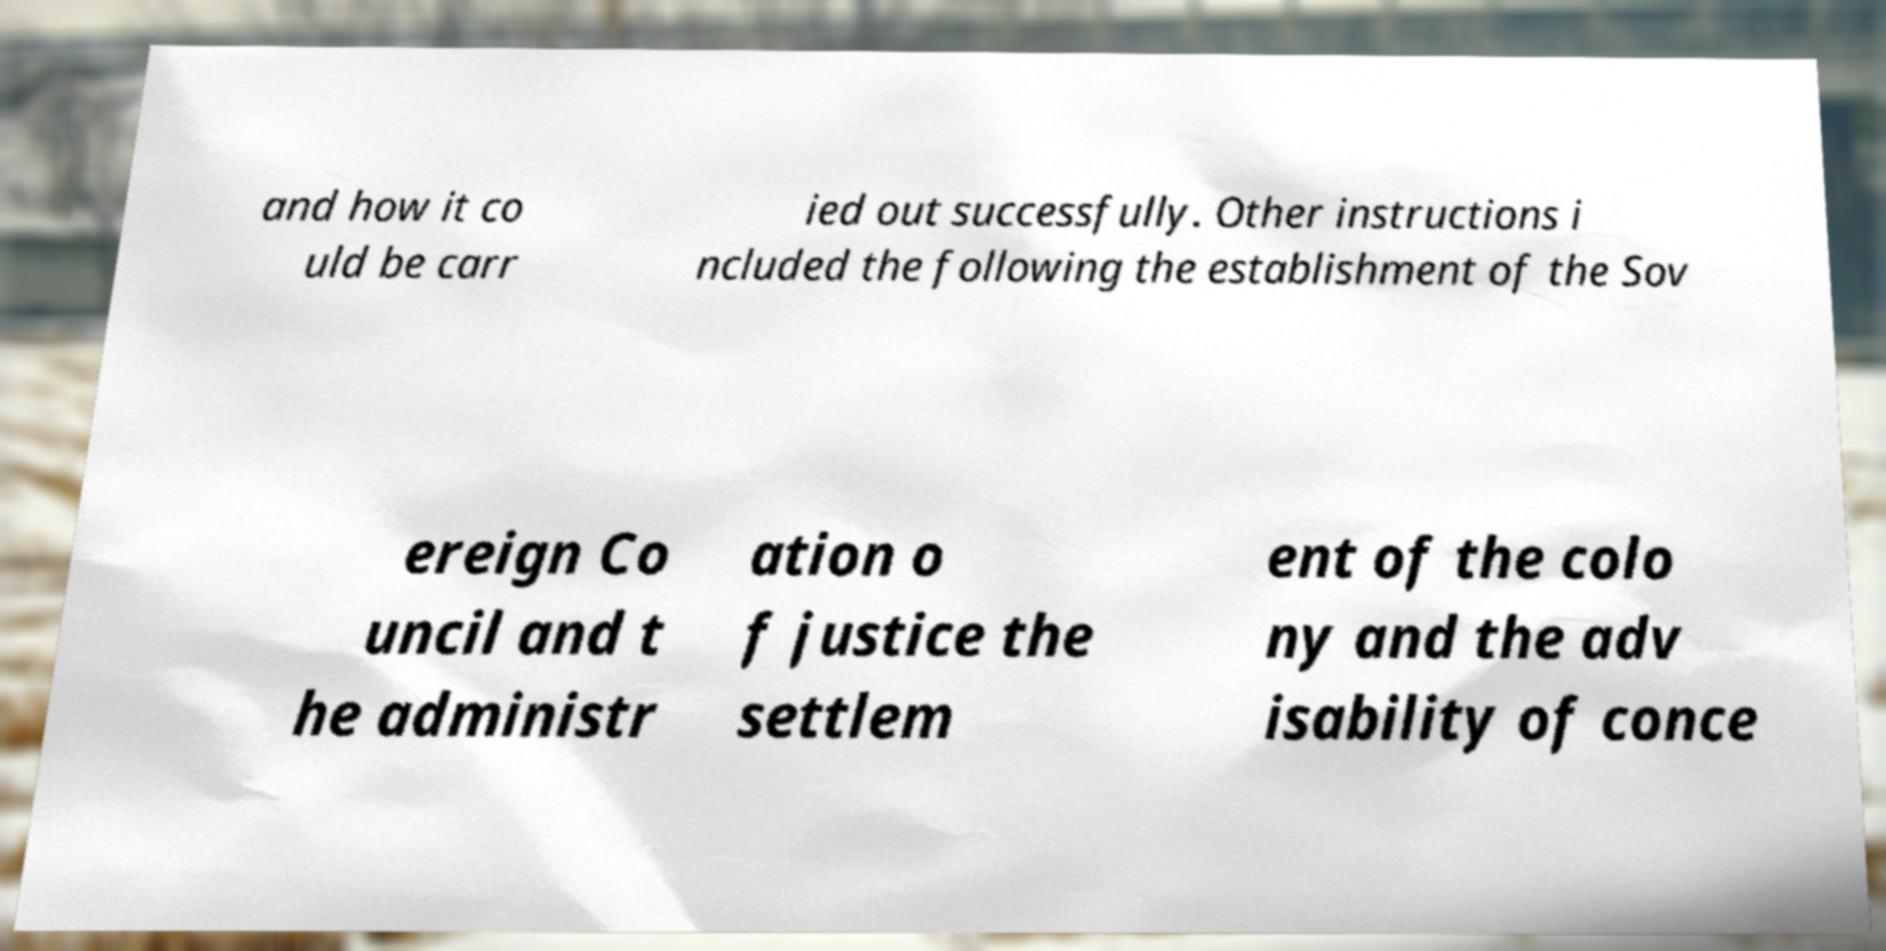Please read and relay the text visible in this image. What does it say? and how it co uld be carr ied out successfully. Other instructions i ncluded the following the establishment of the Sov ereign Co uncil and t he administr ation o f justice the settlem ent of the colo ny and the adv isability of conce 